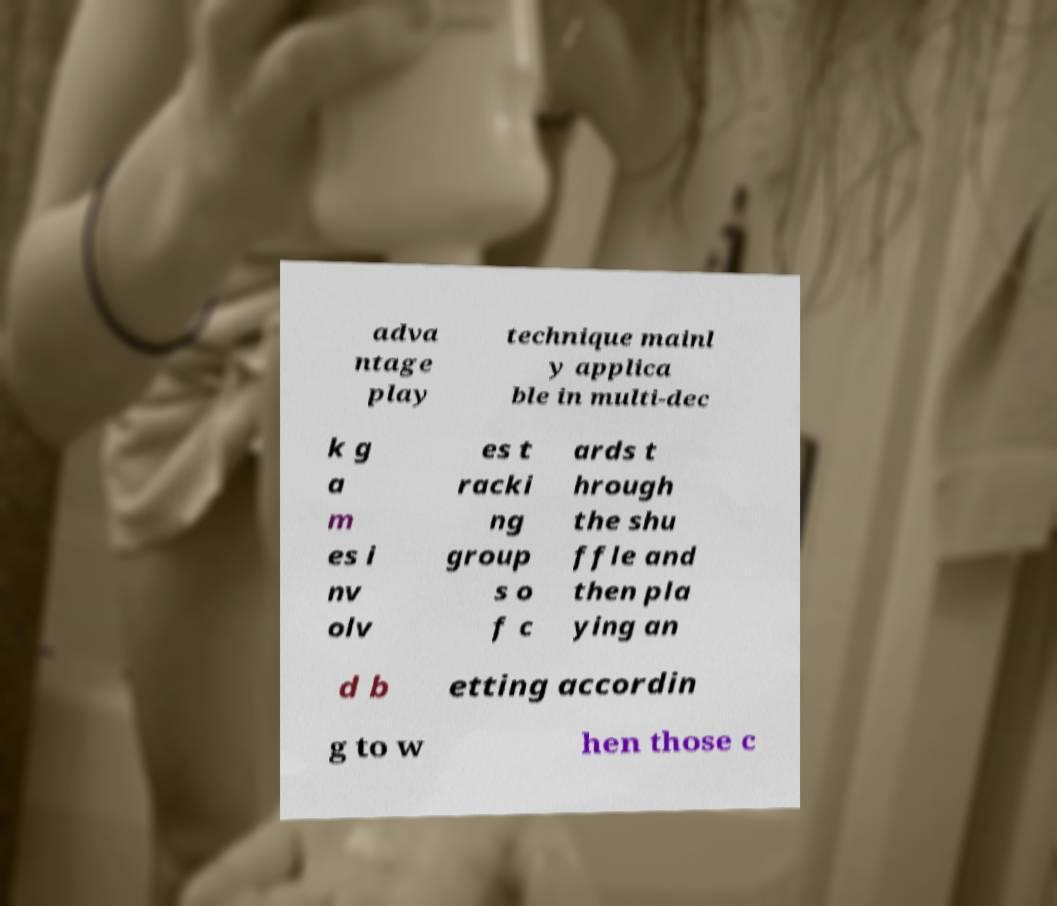There's text embedded in this image that I need extracted. Can you transcribe it verbatim? adva ntage play technique mainl y applica ble in multi-dec k g a m es i nv olv es t racki ng group s o f c ards t hrough the shu ffle and then pla ying an d b etting accordin g to w hen those c 